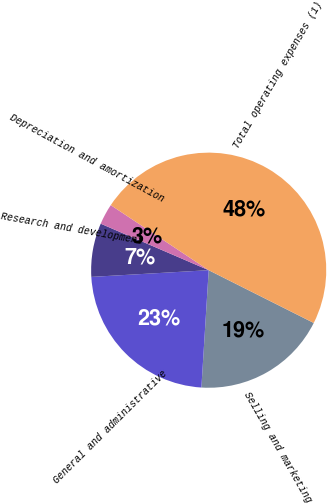Convert chart. <chart><loc_0><loc_0><loc_500><loc_500><pie_chart><fcel>Selling and marketing<fcel>General and administrative<fcel>Research and development<fcel>Depreciation and amortization<fcel>Total operating expenses (1)<nl><fcel>18.58%<fcel>23.1%<fcel>7.38%<fcel>2.86%<fcel>48.07%<nl></chart> 